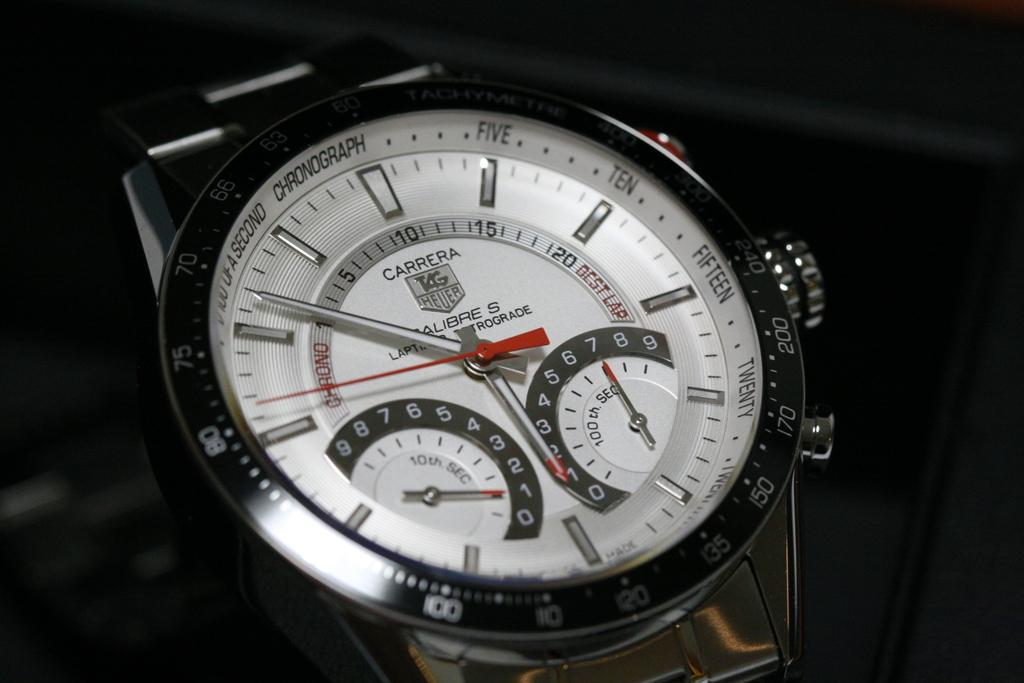<image>
Describe the image concisely. A Carrera Tag Heuer watch in silver with extra dials. 